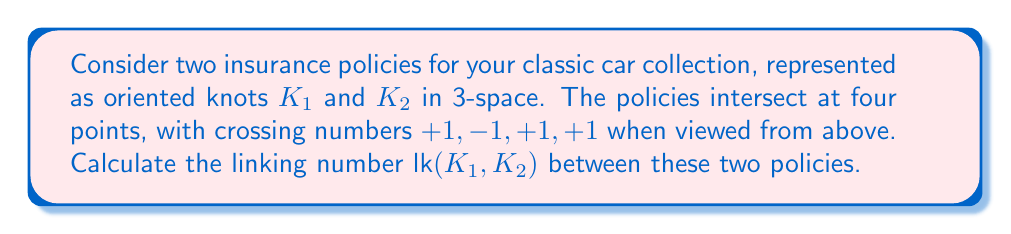Could you help me with this problem? To calculate the linking number between two knots, we follow these steps:

1) The linking number is defined as half the sum of the signed crossing numbers:

   $$\text{lk}(K_1, K_2) = \frac{1}{2} \sum_{i} \epsilon_i$$

   where $\epsilon_i$ is the sign of the $i$-th crossing (+1 for right-handed, -1 for left-handed).

2) We are given four crossings with the following signs:
   $+1, -1, +1, +1$

3) Sum these crossing numbers:
   $$\sum_{i} \epsilon_i = (+1) + (-1) + (+1) + (+1) = 2$$

4) Divide the sum by 2:
   $$\text{lk}(K_1, K_2) = \frac{1}{2} (2) = 1$$

The linking number of 1 indicates that the two insurance policies (represented as knots) are linked once, suggesting a fundamental connection between the policies in terms of coverage or conditions.
Answer: $\text{lk}(K_1, K_2) = 1$ 